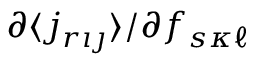<formula> <loc_0><loc_0><loc_500><loc_500>\partial \langle j _ { r { \imath \jmath } } \rangle / \partial f _ { s { \kappa \ell } }</formula> 